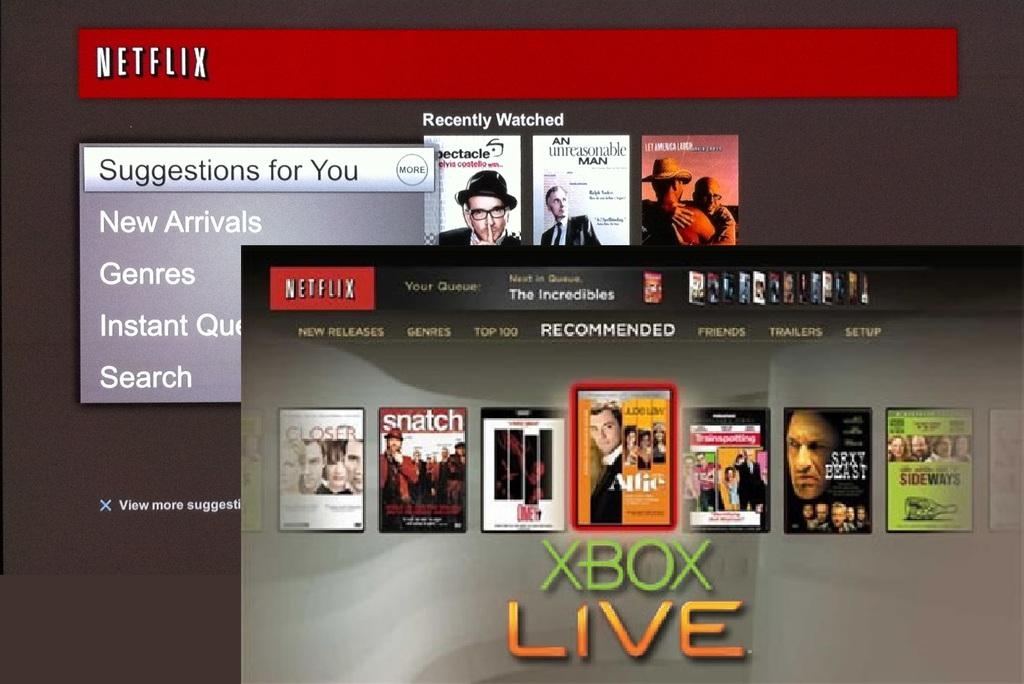What type of content is displayed in the image? The image is of a website. What can be found on the website? There is text on the website. Is there a stove visible in the image? No, there is no stove present in the image. The image is of a website, not a kitchen or any other setting where a stove might be found. 